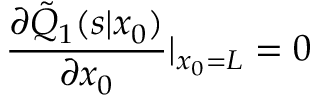<formula> <loc_0><loc_0><loc_500><loc_500>\frac { \partial \tilde { Q } _ { 1 } ( s | x _ { 0 } ) } { \partial x _ { 0 } } | _ { x _ { 0 } = L } = 0</formula> 